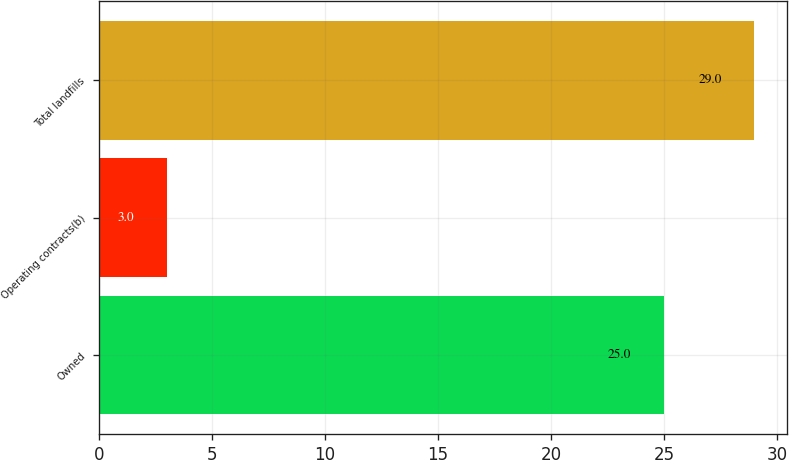Convert chart. <chart><loc_0><loc_0><loc_500><loc_500><bar_chart><fcel>Owned<fcel>Operating contracts(b)<fcel>Total landfills<nl><fcel>25<fcel>3<fcel>29<nl></chart> 